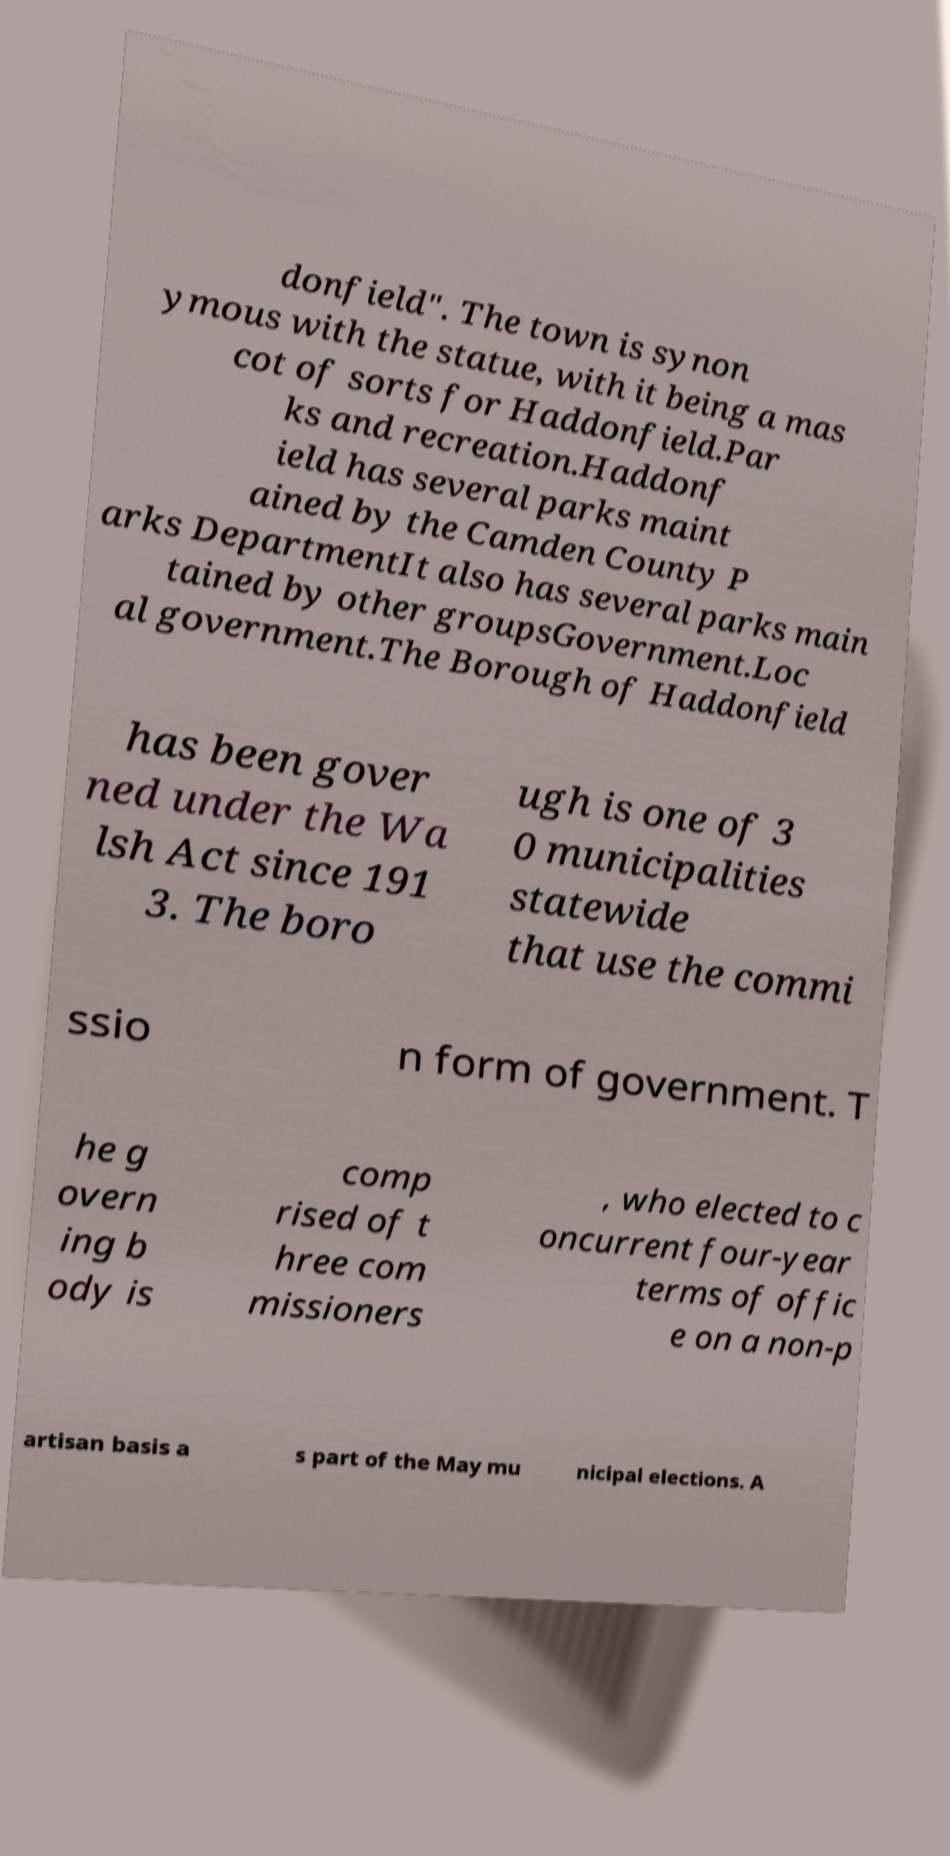For documentation purposes, I need the text within this image transcribed. Could you provide that? donfield". The town is synon ymous with the statue, with it being a mas cot of sorts for Haddonfield.Par ks and recreation.Haddonf ield has several parks maint ained by the Camden County P arks DepartmentIt also has several parks main tained by other groupsGovernment.Loc al government.The Borough of Haddonfield has been gover ned under the Wa lsh Act since 191 3. The boro ugh is one of 3 0 municipalities statewide that use the commi ssio n form of government. T he g overn ing b ody is comp rised of t hree com missioners , who elected to c oncurrent four-year terms of offic e on a non-p artisan basis a s part of the May mu nicipal elections. A 